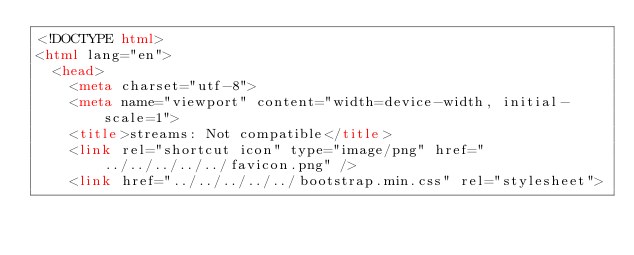Convert code to text. <code><loc_0><loc_0><loc_500><loc_500><_HTML_><!DOCTYPE html>
<html lang="en">
  <head>
    <meta charset="utf-8">
    <meta name="viewport" content="width=device-width, initial-scale=1">
    <title>streams: Not compatible</title>
    <link rel="shortcut icon" type="image/png" href="../../../../../favicon.png" />
    <link href="../../../../../bootstrap.min.css" rel="stylesheet"></code> 